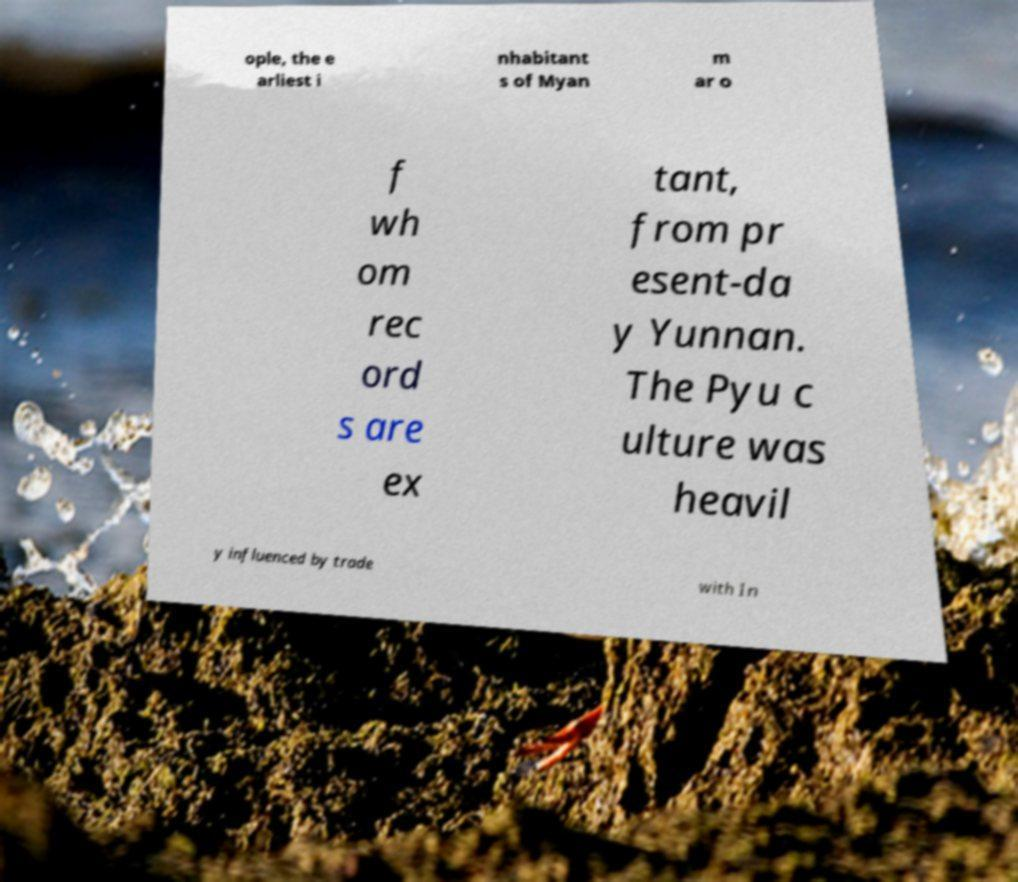Please read and relay the text visible in this image. What does it say? ople, the e arliest i nhabitant s of Myan m ar o f wh om rec ord s are ex tant, from pr esent-da y Yunnan. The Pyu c ulture was heavil y influenced by trade with In 